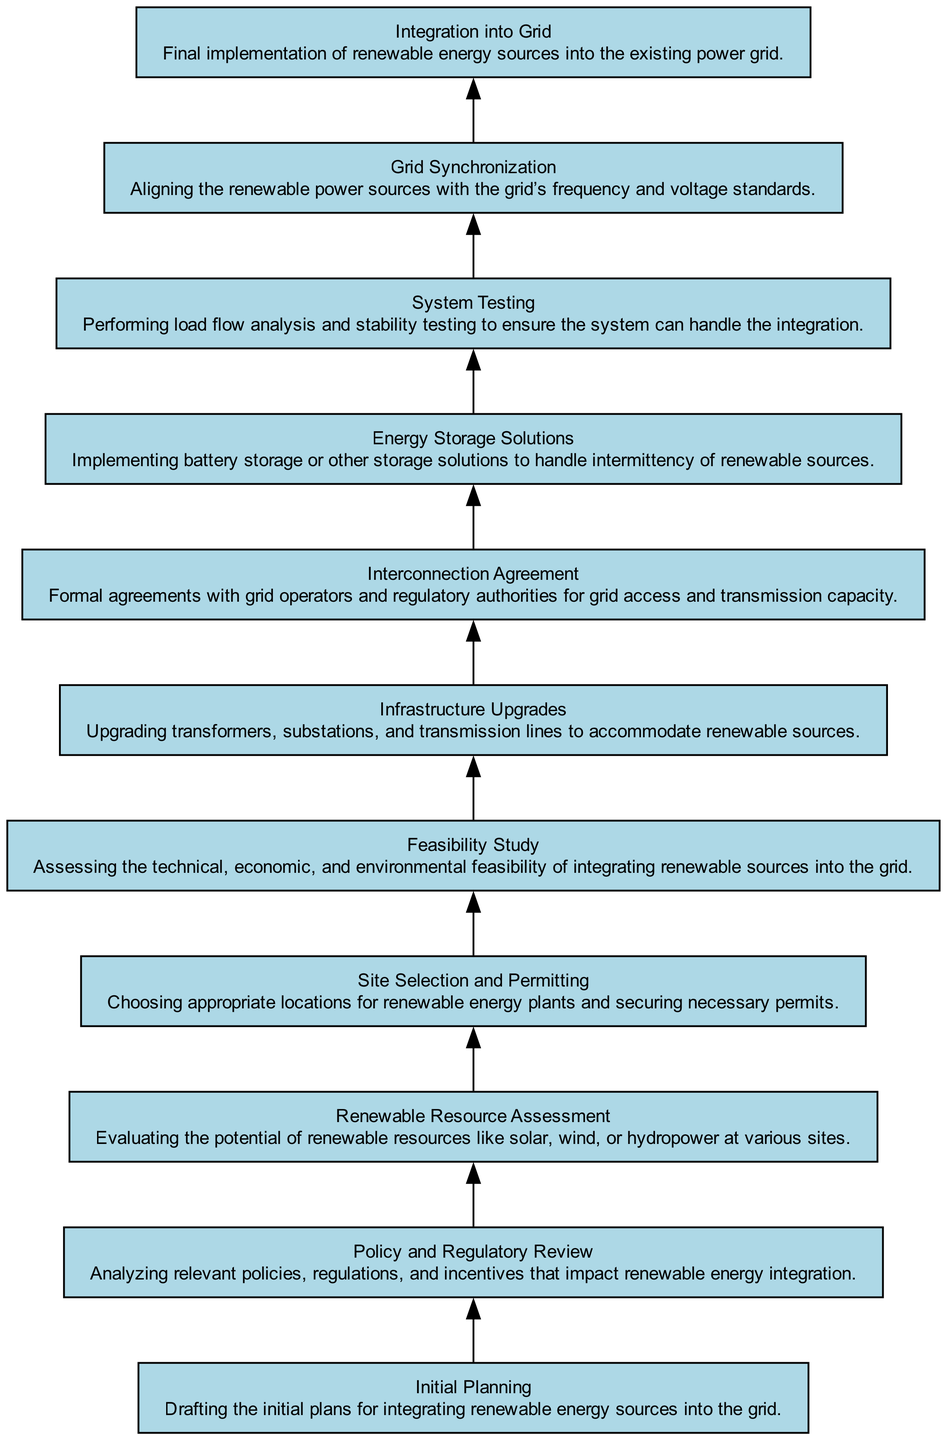What is the final step in the integration process? The final element listed in the flow chart is "Integration into Grid," which represents the culmination of the entire integration process involving renewable energy sources.
Answer: Integration into Grid How many total elements are in the diagram? By counting the different nodes listed in the elements list, we find there are ten distinct elements, each representing a step in the integration process.
Answer: Ten Which process requires the completion of an interconnection agreement? The "Energy Storage Solutions" is the element that follows the "Interconnection Agreement," indicating that the completion of an interconnection agreement is necessary before implementing energy storage solutions.
Answer: Energy Storage Solutions What is the first step in the integration of renewable energy sources? The flow chart indicates that "Initial Planning" is the first step that outlines the initial strategies for integrating renewable energy sources into the power grid.
Answer: Initial Planning Which element comes directly after the "Grid Synchronization"? Following "Grid Synchronization," the next step is "System Testing," which involves validating the grid integration with load flow and stability tests.
Answer: System Testing Which two elements are directly linked before the "Infrastructure Upgrades"? The elements linked immediately before "Infrastructure Upgrades" are "Interconnection Agreement" and "Feasibility Study," showing the dependency between these processes for successful upgrades.
Answer: Interconnection Agreement and Feasibility Study How does "Policy and Regulatory Review" relate to "Renewable Resource Assessment"? The flow indicates that "Policy and Regulatory Review" precedes "Renewable Resource Assessment," meaning it provides necessary context and guidelines before assessing renewable resources.
Answer: It precedes it What is the purpose of the "Feasibility Study"? The "Feasibility Study" aims to evaluate the technical, economic, and environmental aspects of integrating renewable sources, highlighting its critical role in decision-making for the integration.
Answer: Assessing feasibility What type of energy solutions are considered after the "System Testing"? Following "System Testing," the implementation of "Energy Storage Solutions" is the next step, aimed at managing the variability of renewable energy sources.
Answer: Energy Storage Solutions 